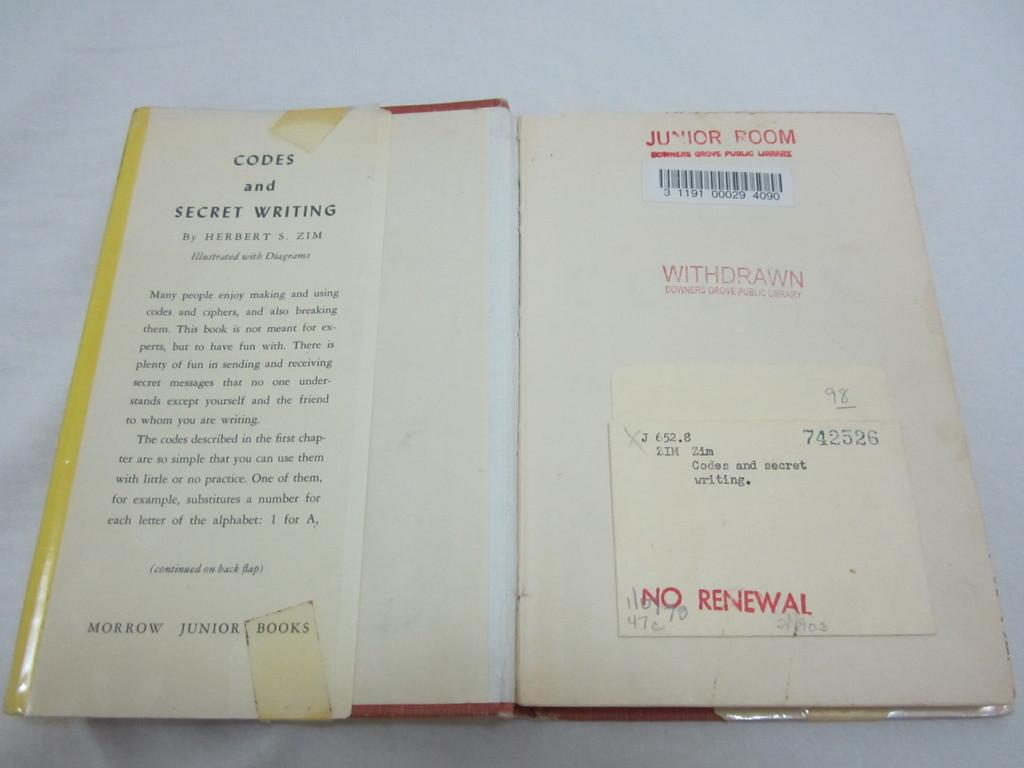<image>
Present a compact description of the photo's key features. the word renewal is on the page in the book 